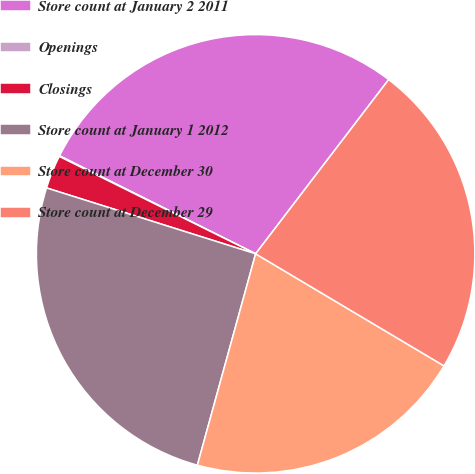<chart> <loc_0><loc_0><loc_500><loc_500><pie_chart><fcel>Store count at January 2 2011<fcel>Openings<fcel>Closings<fcel>Store count at January 1 2012<fcel>Store count at December 30<fcel>Store count at December 29<nl><fcel>28.0%<fcel>0.05%<fcel>2.47%<fcel>25.58%<fcel>20.74%<fcel>23.16%<nl></chart> 